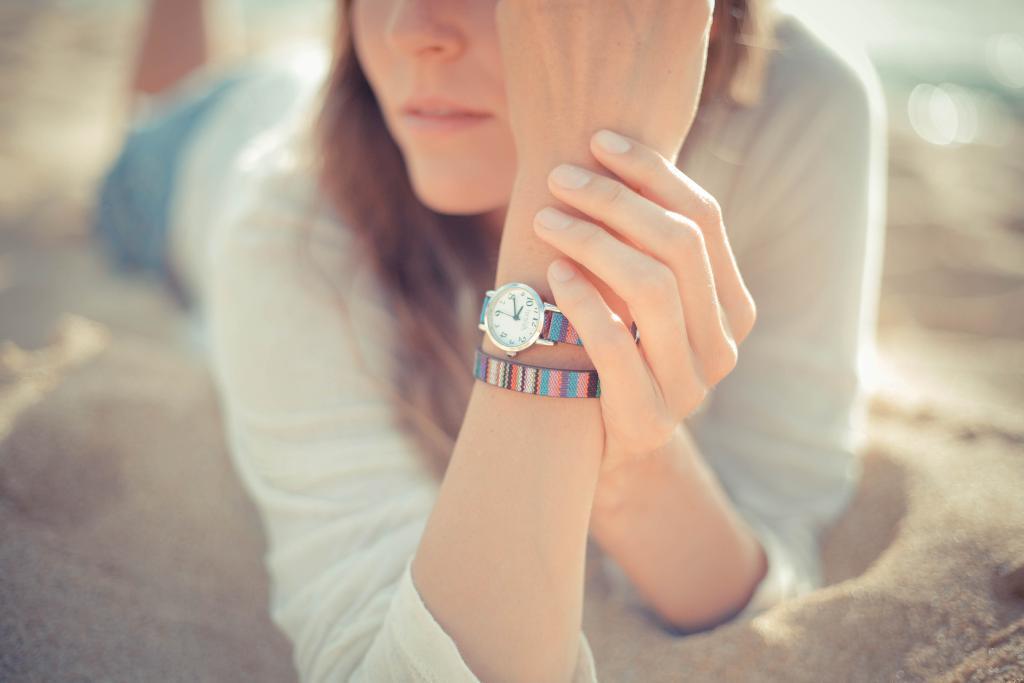Could you give a brief overview of what you see in this image? In this picture there is a man who is lying on the sand. She is wearing t-shirt, short, band and watch. 